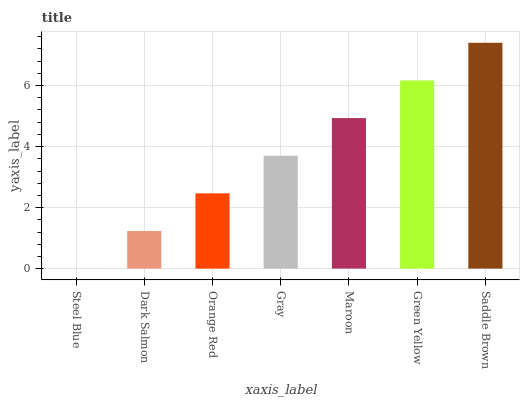Is Steel Blue the minimum?
Answer yes or no. Yes. Is Saddle Brown the maximum?
Answer yes or no. Yes. Is Dark Salmon the minimum?
Answer yes or no. No. Is Dark Salmon the maximum?
Answer yes or no. No. Is Dark Salmon greater than Steel Blue?
Answer yes or no. Yes. Is Steel Blue less than Dark Salmon?
Answer yes or no. Yes. Is Steel Blue greater than Dark Salmon?
Answer yes or no. No. Is Dark Salmon less than Steel Blue?
Answer yes or no. No. Is Gray the high median?
Answer yes or no. Yes. Is Gray the low median?
Answer yes or no. Yes. Is Green Yellow the high median?
Answer yes or no. No. Is Steel Blue the low median?
Answer yes or no. No. 